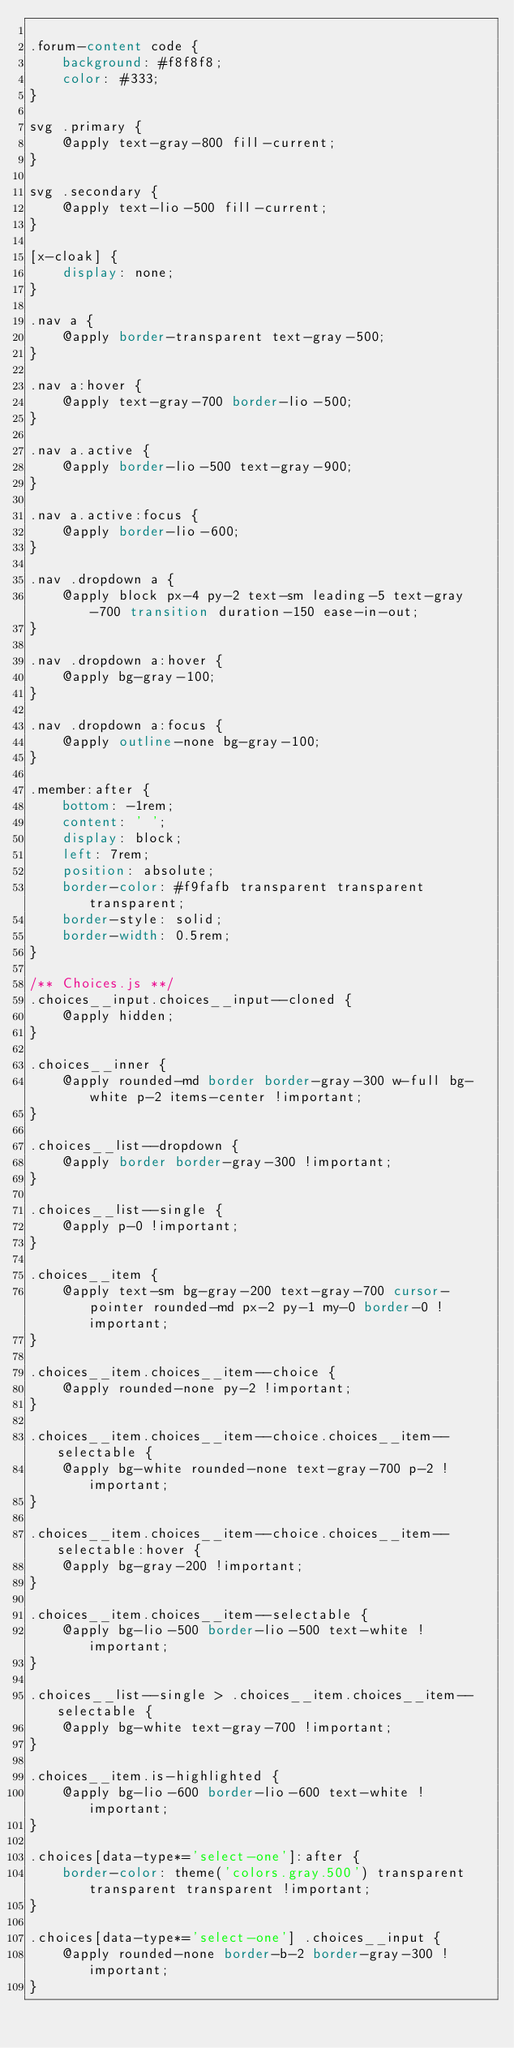Convert code to text. <code><loc_0><loc_0><loc_500><loc_500><_CSS_>
.forum-content code {
    background: #f8f8f8;
    color: #333;
}

svg .primary {
    @apply text-gray-800 fill-current;
}

svg .secondary {
    @apply text-lio-500 fill-current;
}

[x-cloak] {
    display: none;
}

.nav a {
    @apply border-transparent text-gray-500;
}

.nav a:hover {
    @apply text-gray-700 border-lio-500;
}

.nav a.active {
    @apply border-lio-500 text-gray-900;
}

.nav a.active:focus {
    @apply border-lio-600;
}

.nav .dropdown a {
    @apply block px-4 py-2 text-sm leading-5 text-gray-700 transition duration-150 ease-in-out;
}

.nav .dropdown a:hover {
    @apply bg-gray-100;
}

.nav .dropdown a:focus {
    @apply outline-none bg-gray-100;
}

.member:after {
    bottom: -1rem;
    content: ' ';
    display: block;
    left: 7rem;
    position: absolute;
    border-color: #f9fafb transparent transparent transparent;
    border-style: solid;
    border-width: 0.5rem;
}

/** Choices.js **/
.choices__input.choices__input--cloned {
    @apply hidden;
}

.choices__inner {
    @apply rounded-md border border-gray-300 w-full bg-white p-2 items-center !important;
}

.choices__list--dropdown {
    @apply border border-gray-300 !important;
}

.choices__list--single {
    @apply p-0 !important;
}

.choices__item {
    @apply text-sm bg-gray-200 text-gray-700 cursor-pointer rounded-md px-2 py-1 my-0 border-0 !important;
}

.choices__item.choices__item--choice {
    @apply rounded-none py-2 !important;
}

.choices__item.choices__item--choice.choices__item--selectable {
    @apply bg-white rounded-none text-gray-700 p-2 !important;
}

.choices__item.choices__item--choice.choices__item--selectable:hover {
    @apply bg-gray-200 !important;
}

.choices__item.choices__item--selectable {
    @apply bg-lio-500 border-lio-500 text-white !important;
}

.choices__list--single > .choices__item.choices__item--selectable {
    @apply bg-white text-gray-700 !important;
}

.choices__item.is-highlighted {
    @apply bg-lio-600 border-lio-600 text-white !important;
}

.choices[data-type*='select-one']:after {
    border-color: theme('colors.gray.500') transparent transparent transparent !important;
}

.choices[data-type*='select-one'] .choices__input {
    @apply rounded-none border-b-2 border-gray-300 !important;
}
</code> 